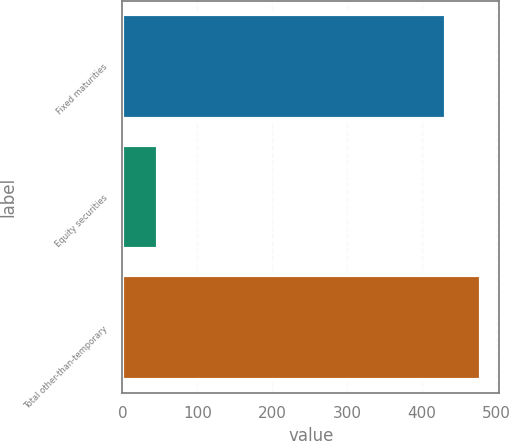<chart> <loc_0><loc_0><loc_500><loc_500><bar_chart><fcel>Fixed maturities<fcel>Equity securities<fcel>Total other-than-temporary<nl><fcel>432<fcel>47.3<fcel>479.3<nl></chart> 